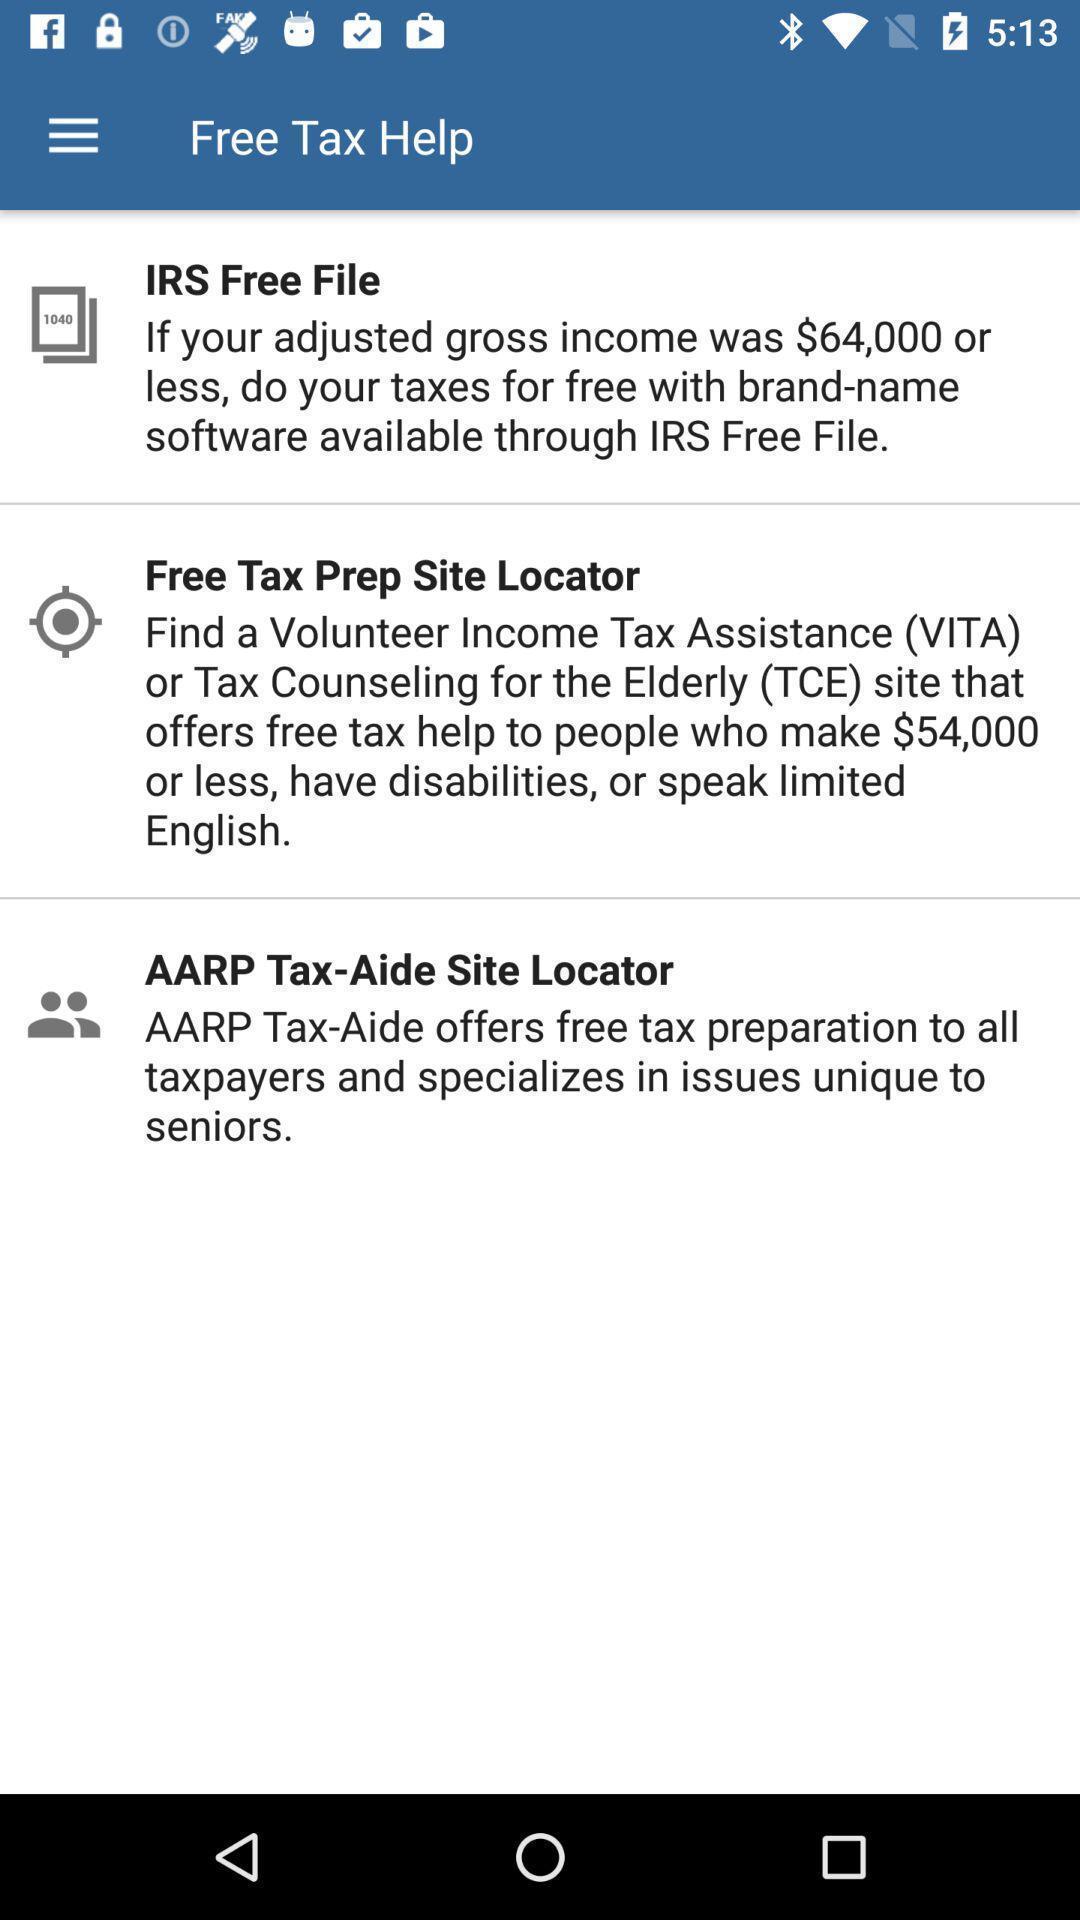Provide a textual representation of this image. Page displaying the information of the free tax help. 